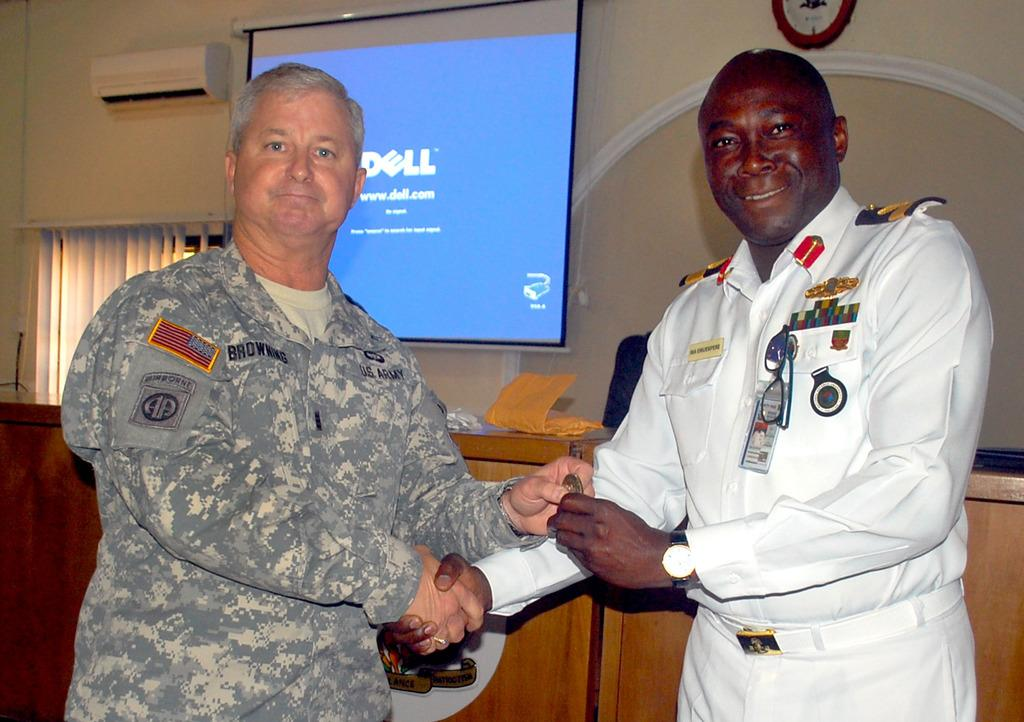<image>
Relay a brief, clear account of the picture shown. The presentation was made by Browning of the U.S. Army. 